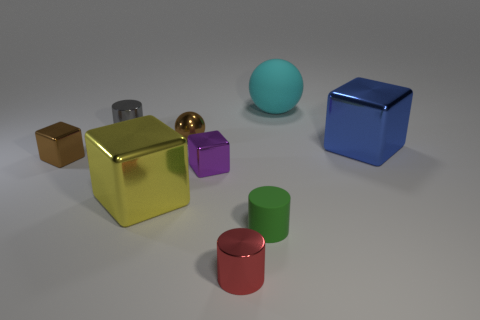What number of objects are either tiny blue metallic blocks or small blocks? The image displays a total of two objects that fit the description: one tiny blue metallic block on the right and one small purple block near the center. 